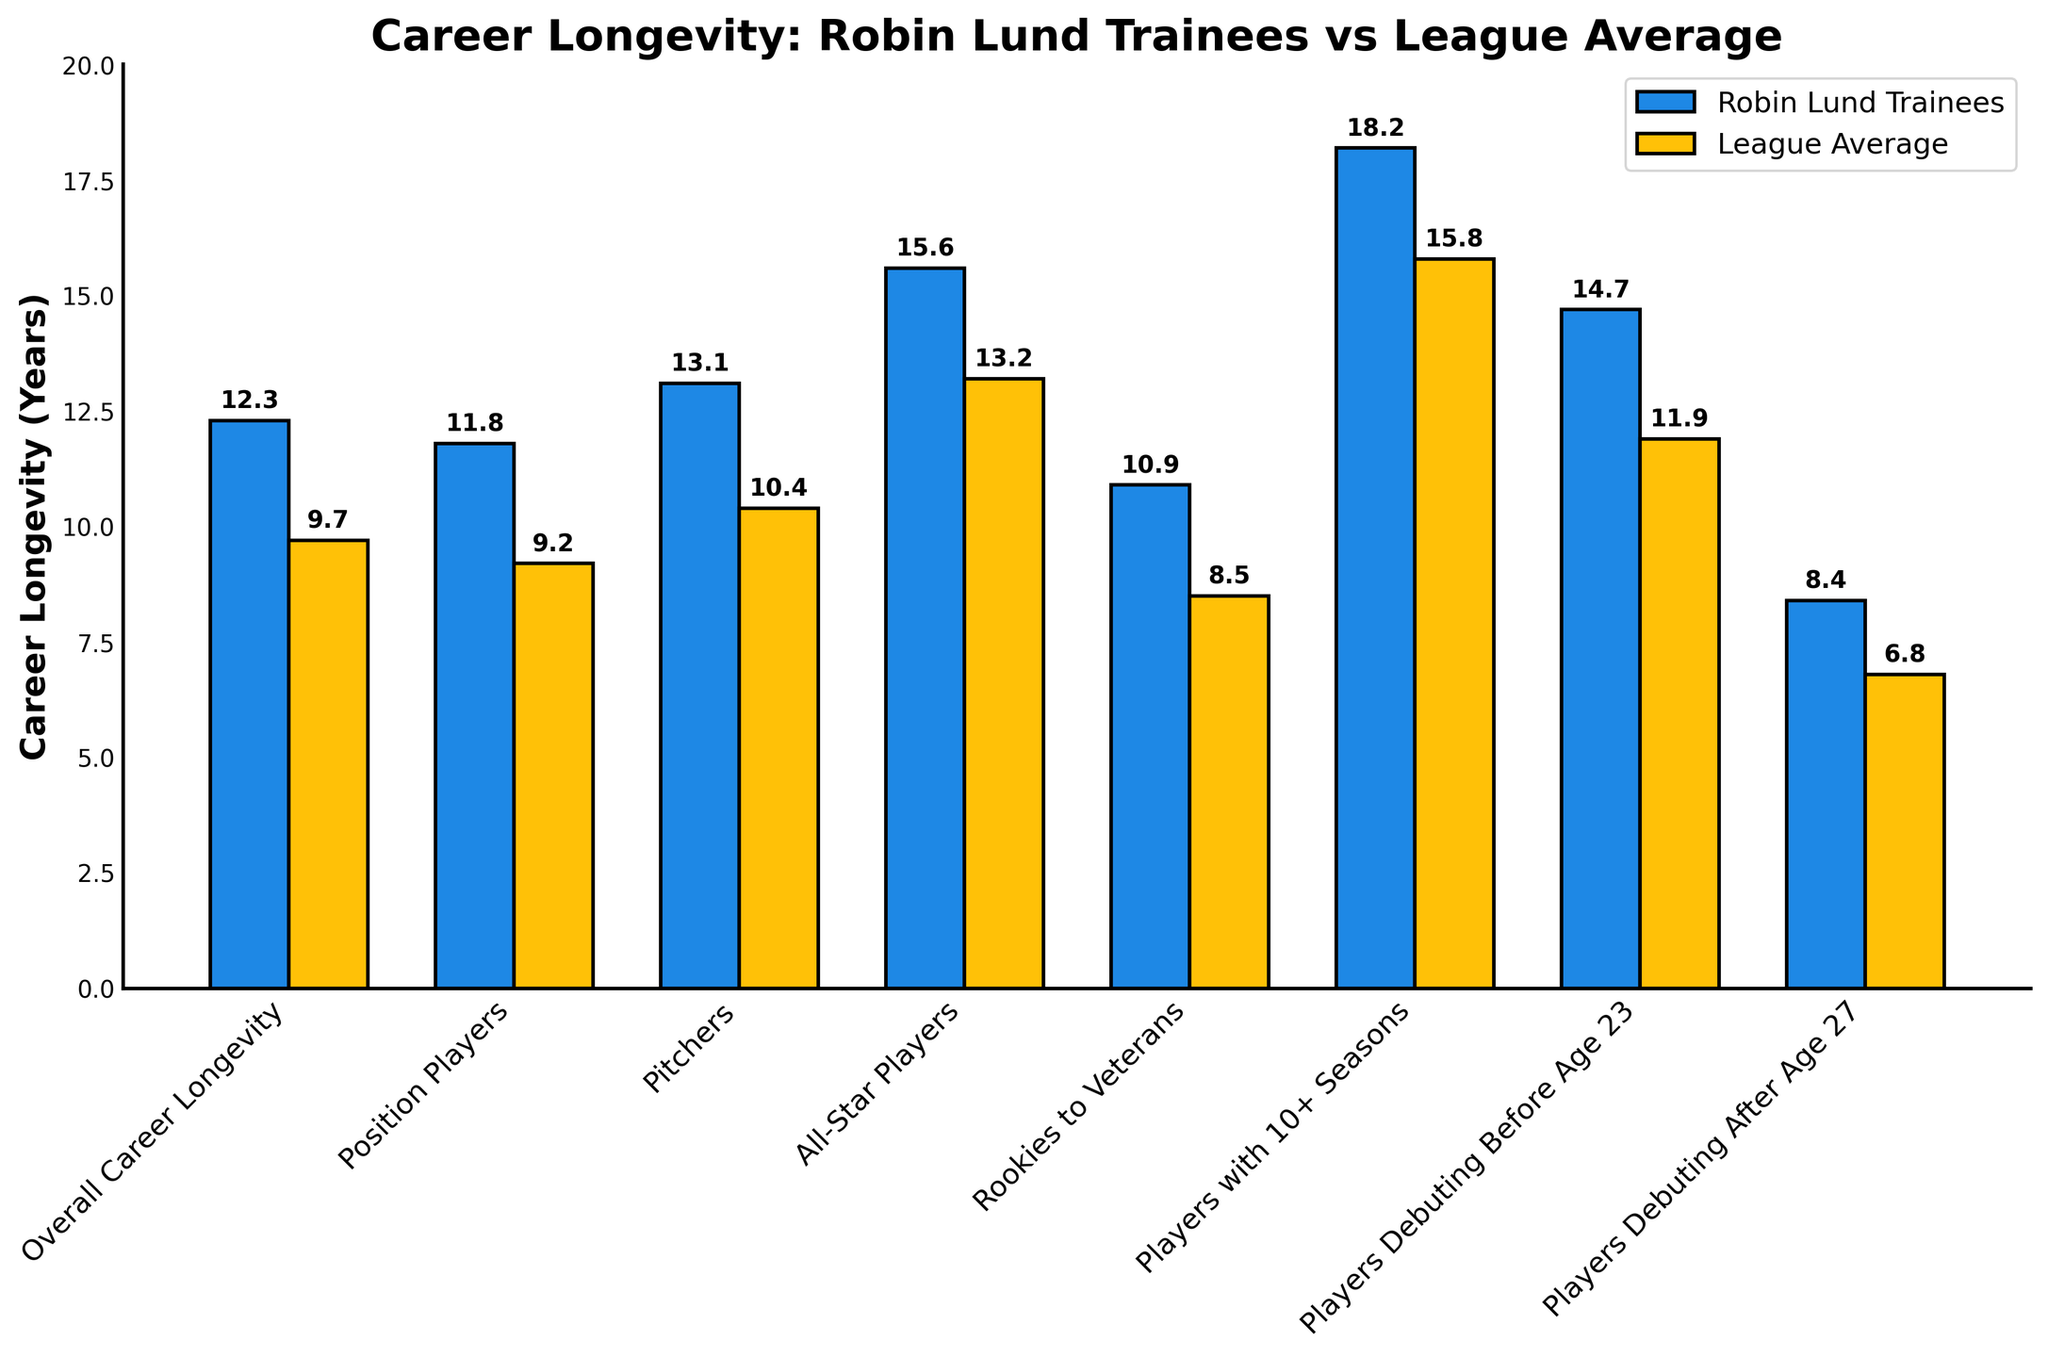what is the difference in overall career longevity between Robin Lund trainees and the league average? The height of the "Overall Career Longevity" bar for Robin Lund trainees is 12.3 years and for the league average is 9.7 years. Subtracting the league average from the trainees' value gives 12.3 - 9.7 = 2.6 years.
Answer: 2.6 years Which category shows the largest difference in career longevity between Robin Lund trainees and the league average? By visually inspecting the biggest gap between the heights of the two bars for each category, "Players with 10+ Seasons" shows the largest difference between the two values. Robin Lund trainees have a career longevity of 18.2 years, while the league average is 15.8 years.
Answer: Players with 10+ Seasons In which category do league average players have a career longevity of less than 9 years? By inspecting the height of the bars for the league average, only the "Players Debuting After Age 27" category has a career longevity of 6.8 years, which is less than 9 years.
Answer: Players Debuting After Age 27 How much longer is the average career longevity of All-Star players who trained under Robin Lund compared to the league average? The height of the "All-Star Players" bar for Robin Lund trainees is 15.6 years, and for the league average, it is 13.2 years. Subtracting the league average from the Robin Lund trainees' value gives 15.6 - 13.2 = 2.4 years.
Answer: 2.4 years What is the career longevity for position players trained under Robin Lund? The height of the "Position Players" bar for Robin Lund trainees is 11.8 years.
Answer: 11.8 years Which group has the smaller difference in career longevity between Robin Lund trainees and the league average, Position Players or Pitchers? The difference for Position Players is 11.8 (Robin Lund) - 9.2 (League) = 2.6 years, and for Pitchers, it is 13.1 (Robin Lund) - 10.4 (League) = 2.7 years. Comparing these two differences, Position Players have a smaller difference of 2.6 years compared to Pitchers' 2.7 years.
Answer: Position Players On average, how much longer do players who trained under Robin Lund last compared to the league average? Sum the career longevity of Robin Lund trainees (12.3 + 11.8 + 13.1 + 15.6 + 10.9 + 18.2 + 14.7 + 8.4 = 105) and the league average (9.7 + 9.2 + 10.4 + 13.2 + 8.5 + 15.8 + 11.9 + 6.8 = 85.5). Divide by the number of categories (8). The average is (105/8) - (85.5/8) = 13.125 - 10.6875 = 2.4375.
Answer: 2.44 years For which category is the league average most similar to the career longevity of Robin Lund trainees? By comparing the heights of the bars, the "Rookies to Veterans" category shows similar lengths. Robin Lund trainees have 10.9 years and the league average is 8.5 years, giving a smaller difference compared to other categories.
Answer: Rookies to Veterans 